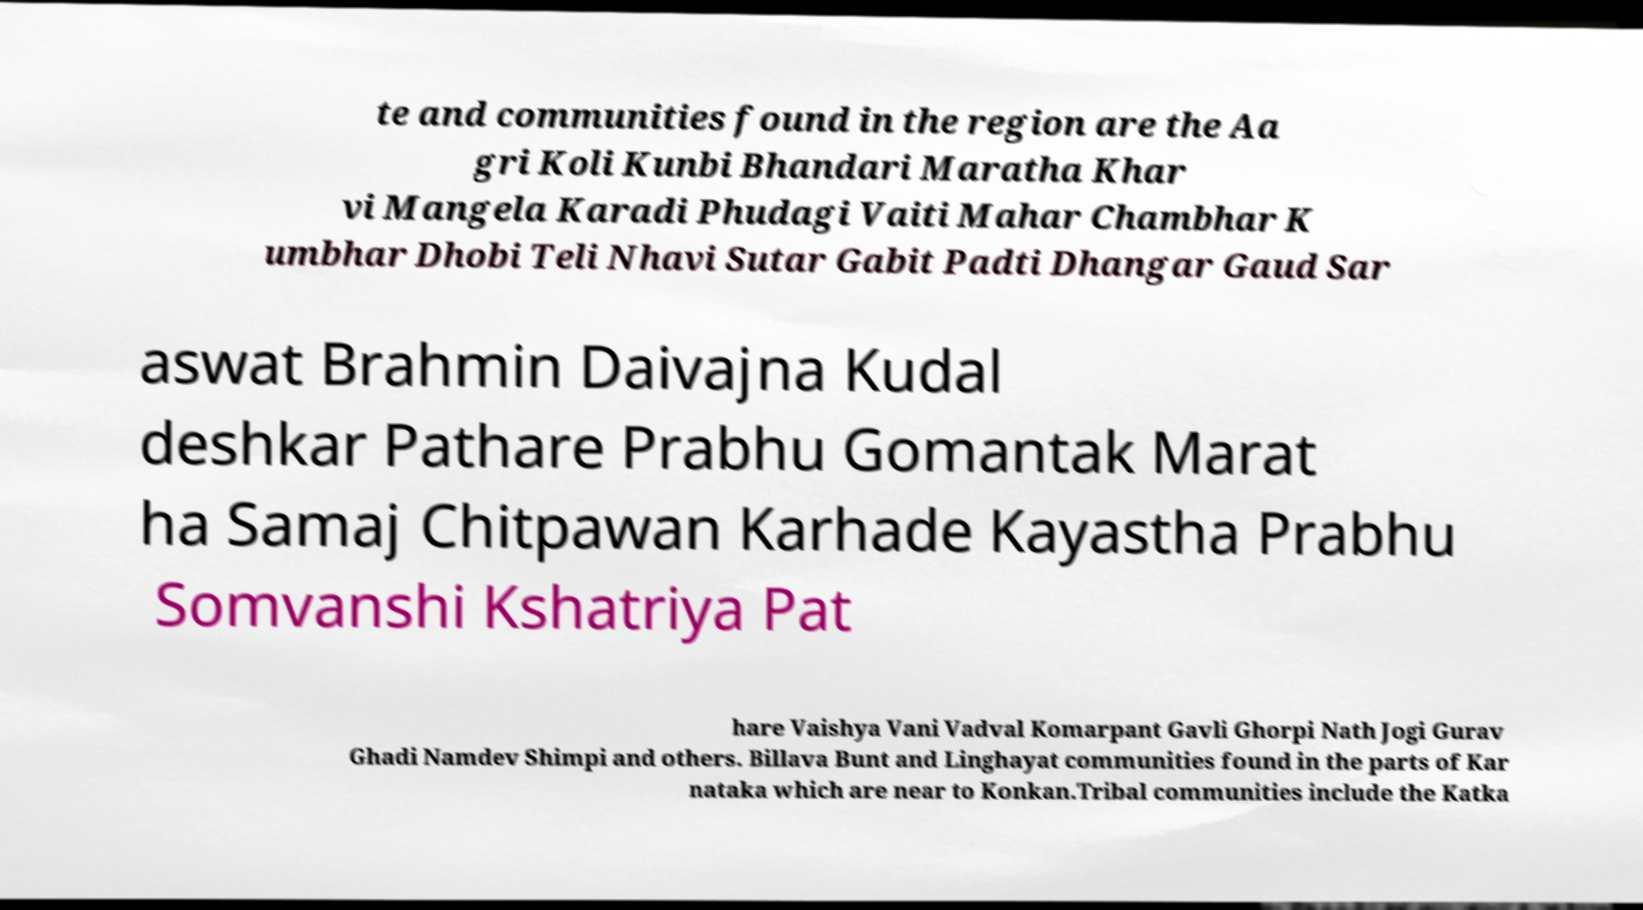For documentation purposes, I need the text within this image transcribed. Could you provide that? te and communities found in the region are the Aa gri Koli Kunbi Bhandari Maratha Khar vi Mangela Karadi Phudagi Vaiti Mahar Chambhar K umbhar Dhobi Teli Nhavi Sutar Gabit Padti Dhangar Gaud Sar aswat Brahmin Daivajna Kudal deshkar Pathare Prabhu Gomantak Marat ha Samaj Chitpawan Karhade Kayastha Prabhu Somvanshi Kshatriya Pat hare Vaishya Vani Vadval Komarpant Gavli Ghorpi Nath Jogi Gurav Ghadi Namdev Shimpi and others. Billava Bunt and Linghayat communities found in the parts of Kar nataka which are near to Konkan.Tribal communities include the Katka 